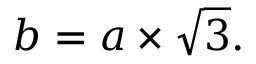<formula> <loc_0><loc_0><loc_500><loc_500>b = a \times { \sqrt { 3 } } .</formula> 